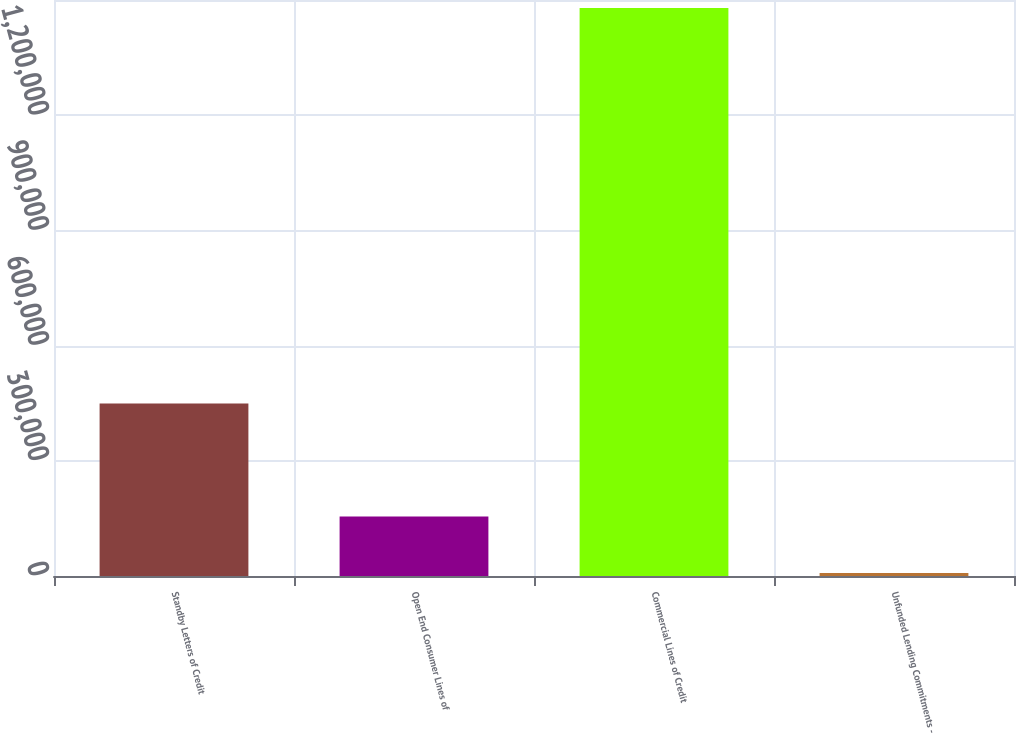Convert chart to OTSL. <chart><loc_0><loc_0><loc_500><loc_500><bar_chart><fcel>Standby Letters of Credit<fcel>Open End Consumer Lines of<fcel>Commercial Lines of Credit<fcel>Unfunded Lending Commitments -<nl><fcel>449065<fcel>154724<fcel>1.47926e+06<fcel>7553<nl></chart> 